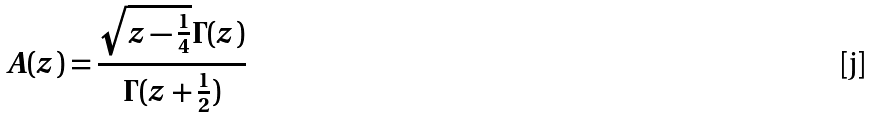<formula> <loc_0><loc_0><loc_500><loc_500>A ( z ) = \frac { \sqrt { z - \frac { 1 } { 4 } } \Gamma ( z ) } { \Gamma ( z + \frac { 1 } { 2 } ) }</formula> 